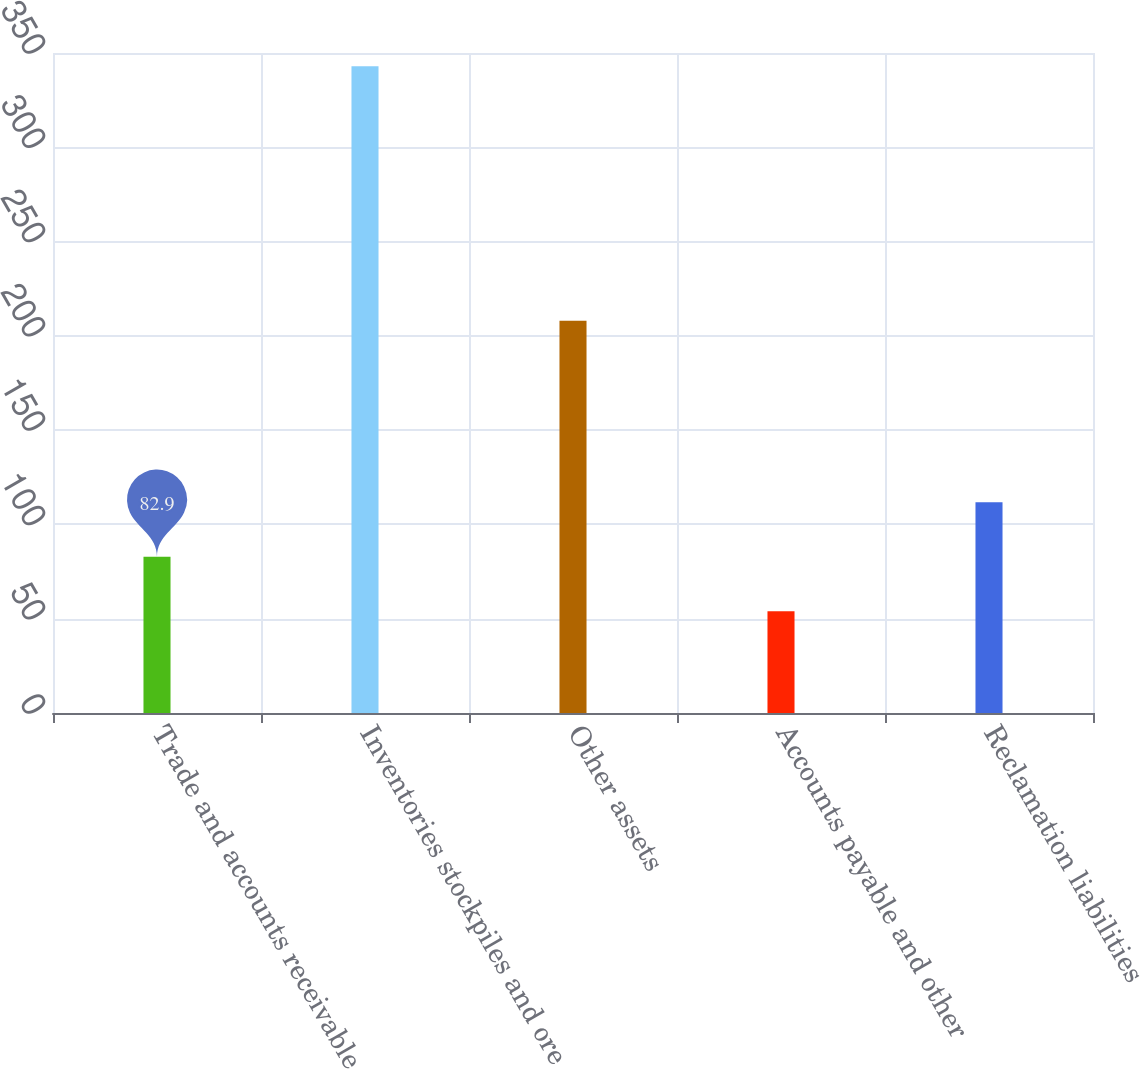Convert chart to OTSL. <chart><loc_0><loc_0><loc_500><loc_500><bar_chart><fcel>Trade and accounts receivable<fcel>Inventories stockpiles and ore<fcel>Other assets<fcel>Accounts payable and other<fcel>Reclamation liabilities<nl><fcel>82.9<fcel>343<fcel>208<fcel>54<fcel>111.8<nl></chart> 